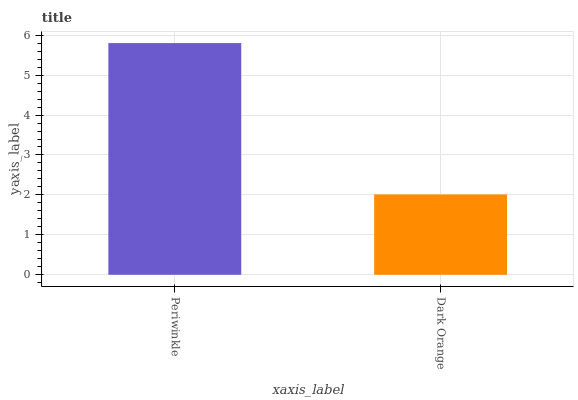Is Dark Orange the minimum?
Answer yes or no. Yes. Is Periwinkle the maximum?
Answer yes or no. Yes. Is Dark Orange the maximum?
Answer yes or no. No. Is Periwinkle greater than Dark Orange?
Answer yes or no. Yes. Is Dark Orange less than Periwinkle?
Answer yes or no. Yes. Is Dark Orange greater than Periwinkle?
Answer yes or no. No. Is Periwinkle less than Dark Orange?
Answer yes or no. No. Is Periwinkle the high median?
Answer yes or no. Yes. Is Dark Orange the low median?
Answer yes or no. Yes. Is Dark Orange the high median?
Answer yes or no. No. Is Periwinkle the low median?
Answer yes or no. No. 